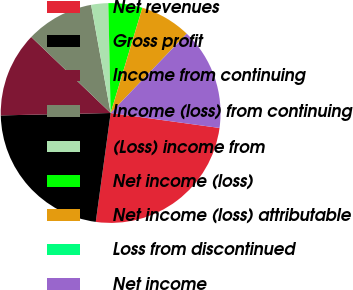<chart> <loc_0><loc_0><loc_500><loc_500><pie_chart><fcel>Net revenues<fcel>Gross profit<fcel>Income from continuing<fcel>Income (loss) from continuing<fcel>(Loss) income from<fcel>Net income (loss)<fcel>Net income (loss) attributable<fcel>Loss from discontinued<fcel>Net income<nl><fcel>24.99%<fcel>22.49%<fcel>12.5%<fcel>10.0%<fcel>2.51%<fcel>5.0%<fcel>7.5%<fcel>0.01%<fcel>15.0%<nl></chart> 